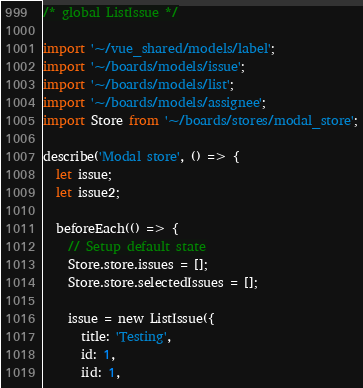<code> <loc_0><loc_0><loc_500><loc_500><_JavaScript_>/* global ListIssue */

import '~/vue_shared/models/label';
import '~/boards/models/issue';
import '~/boards/models/list';
import '~/boards/models/assignee';
import Store from '~/boards/stores/modal_store';

describe('Modal store', () => {
  let issue;
  let issue2;

  beforeEach(() => {
    // Setup default state
    Store.store.issues = [];
    Store.store.selectedIssues = [];

    issue = new ListIssue({
      title: 'Testing',
      id: 1,
      iid: 1,</code> 